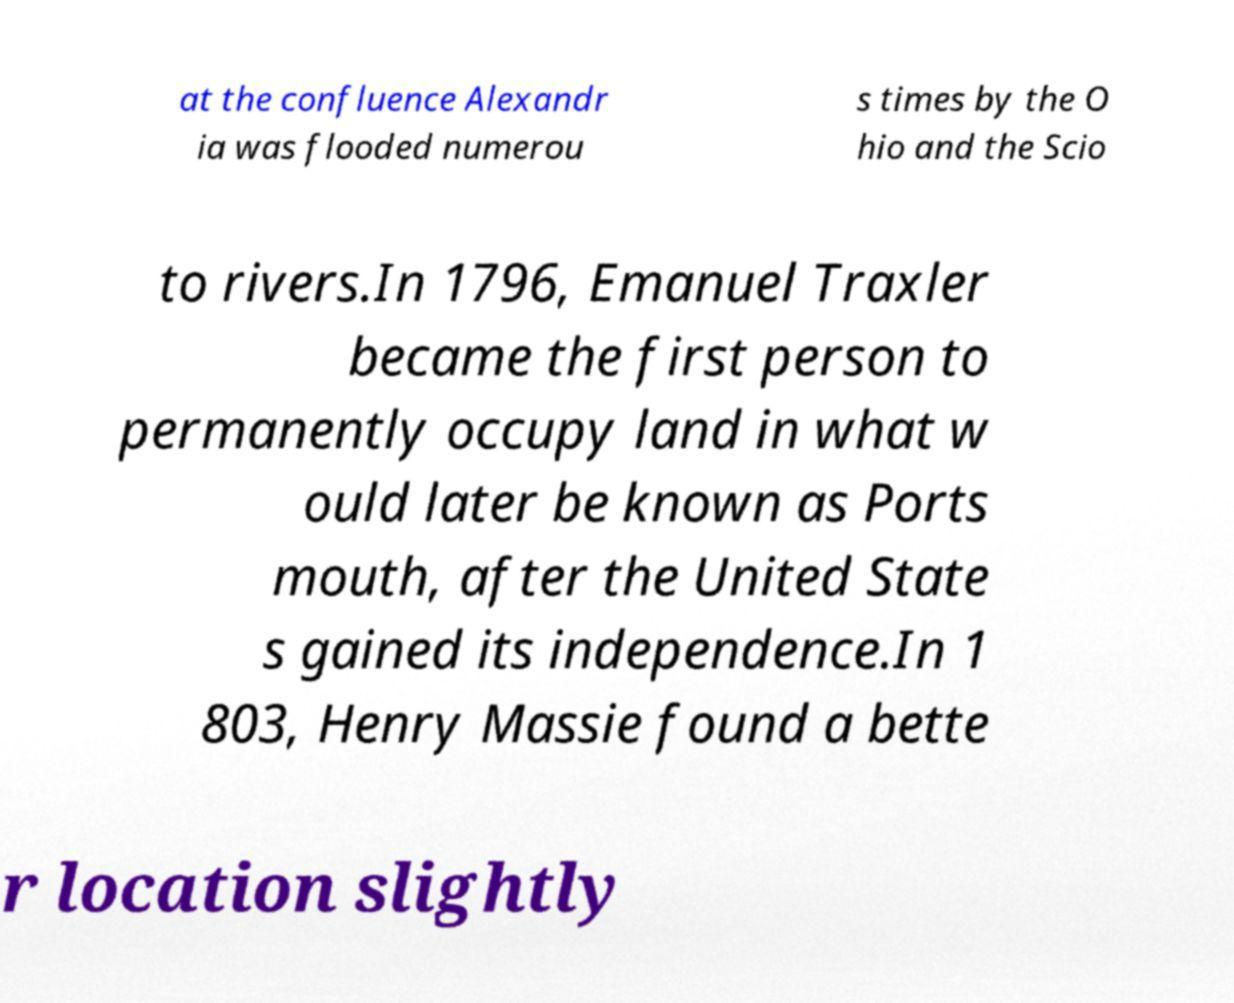Could you extract and type out the text from this image? at the confluence Alexandr ia was flooded numerou s times by the O hio and the Scio to rivers.In 1796, Emanuel Traxler became the first person to permanently occupy land in what w ould later be known as Ports mouth, after the United State s gained its independence.In 1 803, Henry Massie found a bette r location slightly 